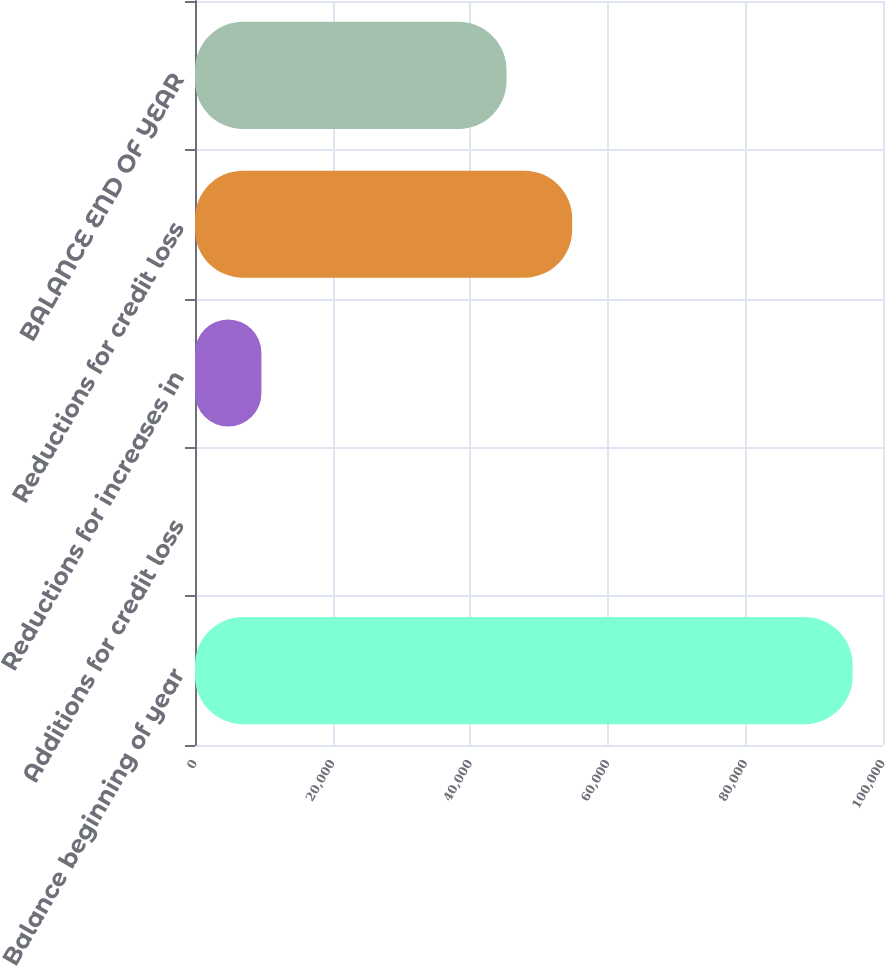<chart> <loc_0><loc_0><loc_500><loc_500><bar_chart><fcel>Balance beginning of year<fcel>Additions for credit loss<fcel>Reductions for increases in<fcel>Reductions for credit loss<fcel>BALANCE END OF YEAR<nl><fcel>95589<fcel>107<fcel>9655.2<fcel>54826.2<fcel>45278<nl></chart> 